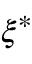Convert formula to latex. <formula><loc_0><loc_0><loc_500><loc_500>\xi ^ { * }</formula> 